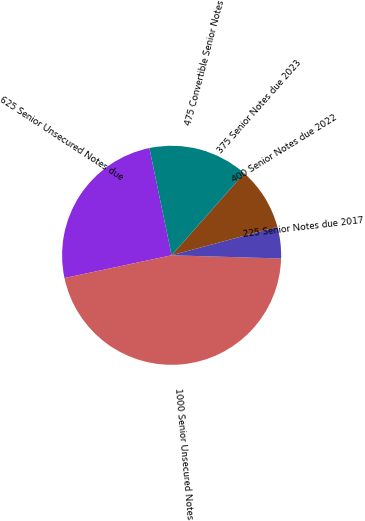Convert chart to OTSL. <chart><loc_0><loc_0><loc_500><loc_500><pie_chart><fcel>625 Senior Unsecured Notes due<fcel>1000 Senior Unsecured Notes<fcel>225 Senior Notes due 2017<fcel>400 Senior Notes due 2022<fcel>375 Senior Notes due 2023<fcel>475 Convertible Senior Notes<nl><fcel>25.08%<fcel>46.2%<fcel>4.65%<fcel>9.27%<fcel>0.04%<fcel>14.76%<nl></chart> 